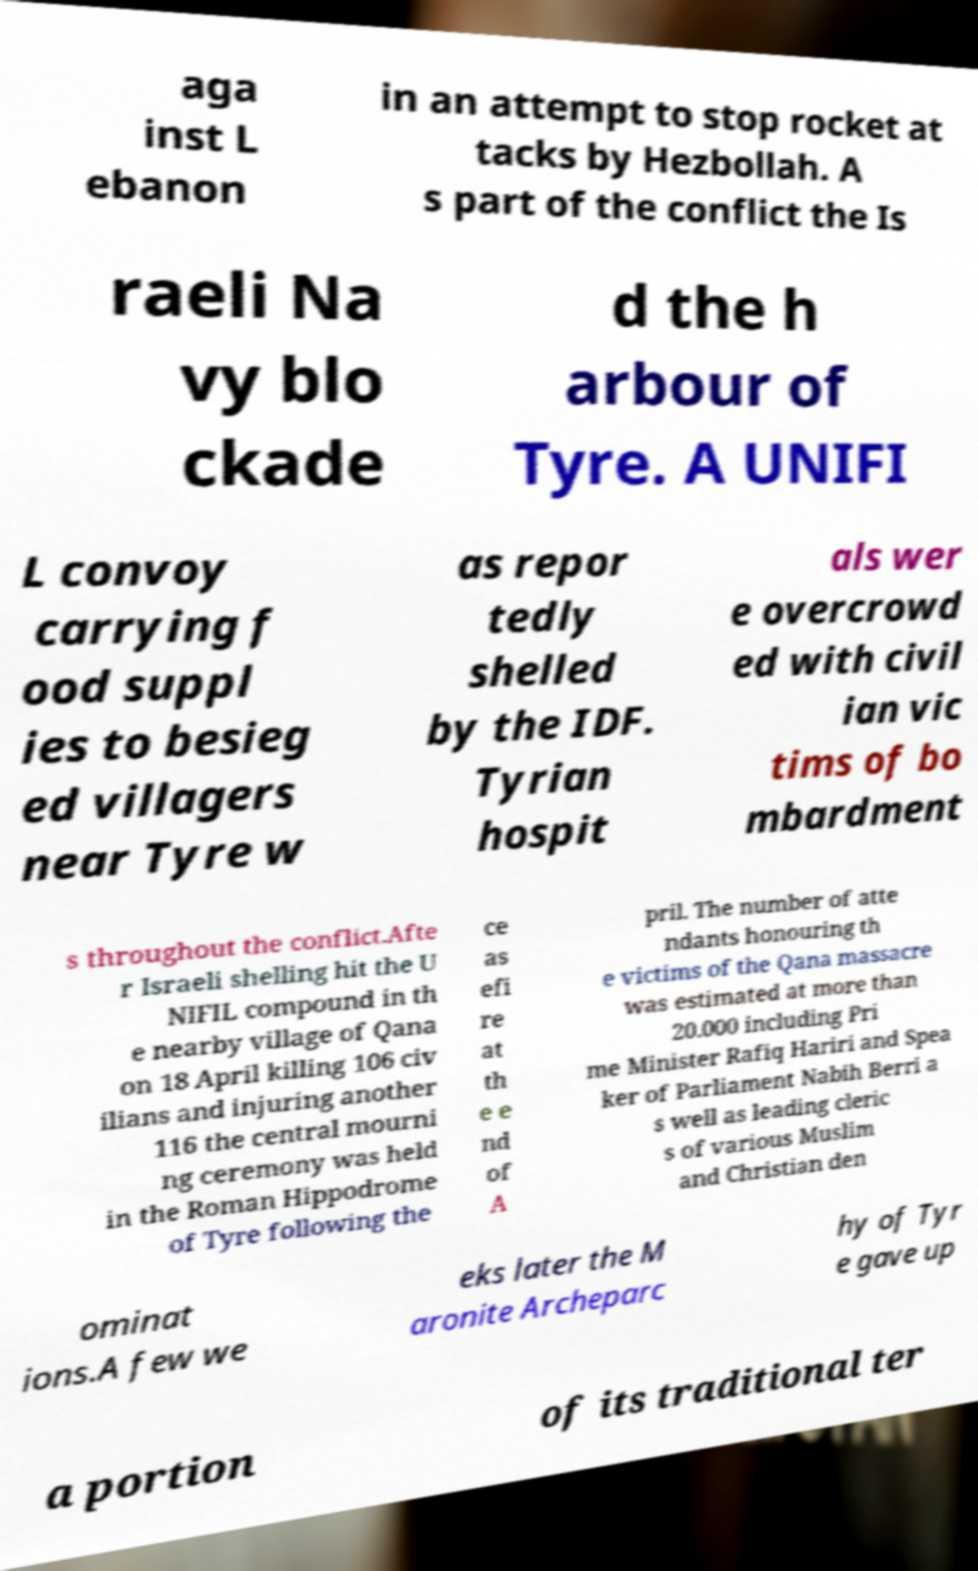Can you read and provide the text displayed in the image?This photo seems to have some interesting text. Can you extract and type it out for me? aga inst L ebanon in an attempt to stop rocket at tacks by Hezbollah. A s part of the conflict the Is raeli Na vy blo ckade d the h arbour of Tyre. A UNIFI L convoy carrying f ood suppl ies to besieg ed villagers near Tyre w as repor tedly shelled by the IDF. Tyrian hospit als wer e overcrowd ed with civil ian vic tims of bo mbardment s throughout the conflict.Afte r Israeli shelling hit the U NIFIL compound in th e nearby village of Qana on 18 April killing 106 civ ilians and injuring another 116 the central mourni ng ceremony was held in the Roman Hippodrome of Tyre following the ce as efi re at th e e nd of A pril. The number of atte ndants honouring th e victims of the Qana massacre was estimated at more than 20.000 including Pri me Minister Rafiq Hariri and Spea ker of Parliament Nabih Berri a s well as leading cleric s of various Muslim and Christian den ominat ions.A few we eks later the M aronite Archeparc hy of Tyr e gave up a portion of its traditional ter 